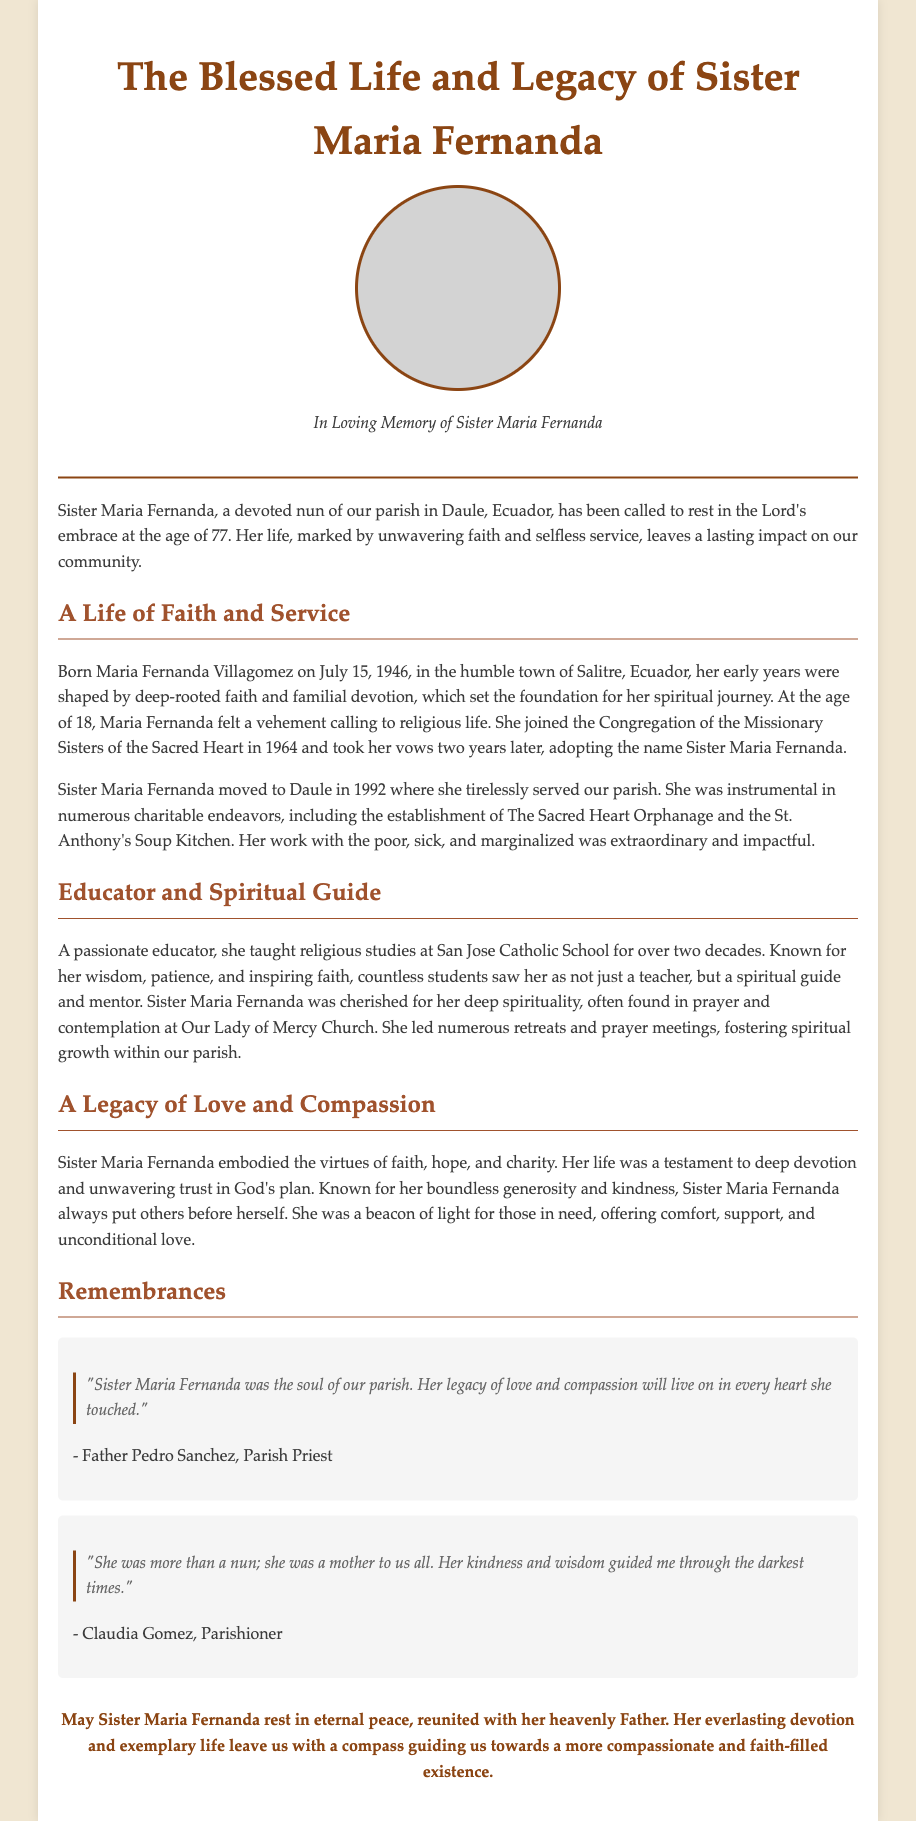What is Sister Maria Fernanda's full name? Sister Maria Fernanda’s full name is mentioned as Maria Fernanda Villagomez in the document.
Answer: Maria Fernanda Villagomez What year did Sister Maria Fernanda join the Congregation? The document states that Sister Maria Fernanda joined the Congregation of the Missionary Sisters of the Sacred Heart in 1964.
Answer: 1964 How many years did Sister Maria Fernanda teach at San Jose Catholic School? The document mentions she taught for over two decades, which is approximately 20 years.
Answer: Over two decades What was one of the charitable endeavors established by Sister Maria Fernanda? The Sacred Heart Orphanage is highlighted as one of the charitable endeavors she established.
Answer: The Sacred Heart Orphanage Who referred to Sister Maria Fernanda as "the soul of our parish"? Father Pedro Sanchez is the one who made this statement about Sister Maria Fernanda in the document.
Answer: Father Pedro Sanchez What virtues did Sister Maria Fernanda embody according to the document? The document describes her embodiment of faith, hope, and charity.
Answer: Faith, hope, and charity What is the age at which Sister Maria Fernanda passed away? The document states that Sister Maria Fernanda passed away at the age of 77.
Answer: 77 What phrase does the document use to describe Sister Maria Fernanda's life? Sister Maria Fernanda's life is described as "a testament to deep devotion and unwavering trust in God's plan."
Answer: A testament to deep devotion and unwavering trust in God's plan What type of events did Sister Maria Fernanda lead in the parish? The document states that she led retreats and prayer meetings in the parish.
Answer: Retreats and prayer meetings 